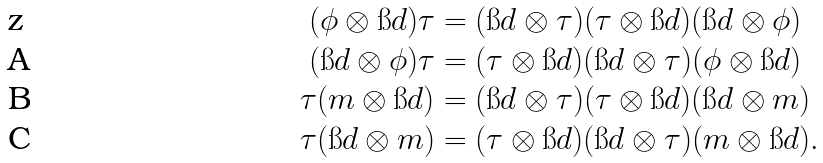Convert formula to latex. <formula><loc_0><loc_0><loc_500><loc_500>( \phi \otimes \i d ) \tau & = ( \i d \otimes \tau ) ( \tau \otimes \i d ) ( \i d \otimes \phi ) \\ ( \i d \otimes \phi ) \tau & = ( \tau \otimes \i d ) ( \i d \otimes \tau ) ( \phi \otimes \i d ) \\ \tau ( m \otimes \i d ) & = ( \i d \otimes \tau ) ( \tau \otimes \i d ) ( \i d \otimes m ) \\ \tau ( \i d \otimes m ) & = ( \tau \otimes \i d ) ( \i d \otimes \tau ) ( m \otimes \i d ) .</formula> 